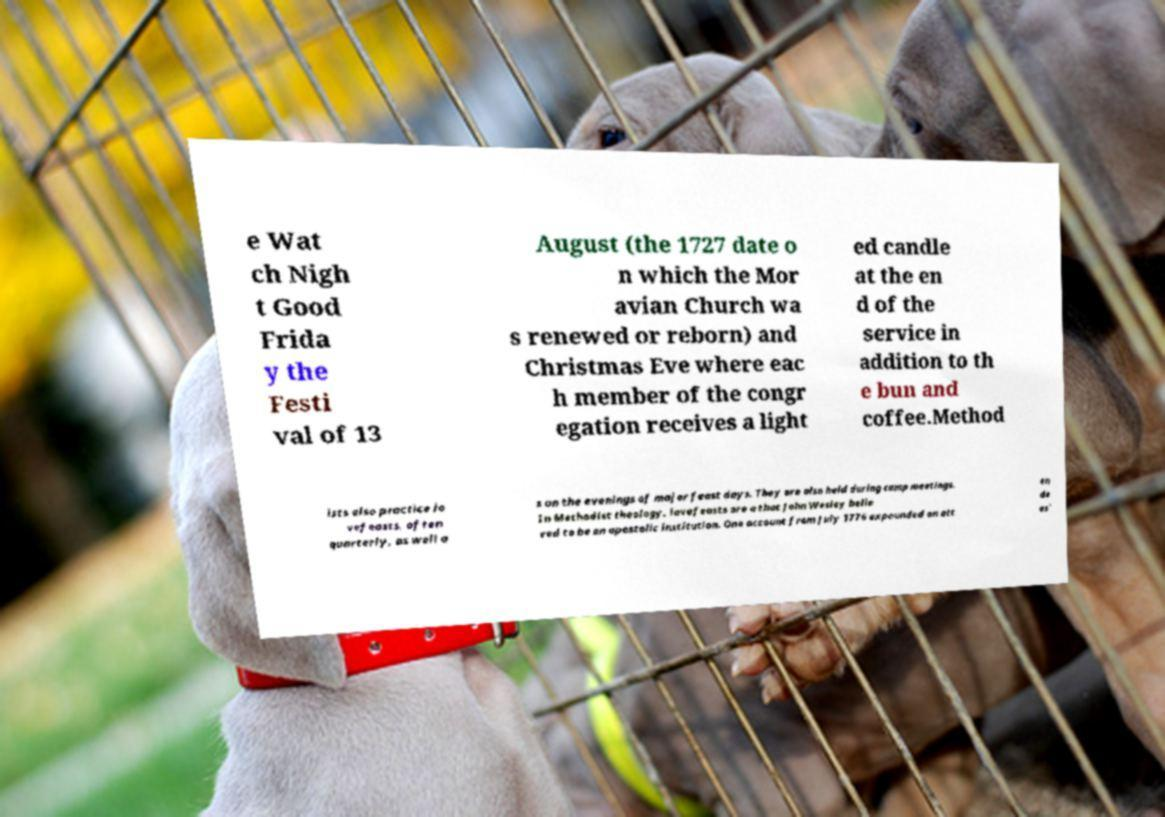Could you assist in decoding the text presented in this image and type it out clearly? e Wat ch Nigh t Good Frida y the Festi val of 13 August (the 1727 date o n which the Mor avian Church wa s renewed or reborn) and Christmas Eve where eac h member of the congr egation receives a light ed candle at the en d of the service in addition to th e bun and coffee.Method ists also practice lo vefeasts, often quarterly, as well a s on the evenings of major feast days. They are also held during camp meetings. In Methodist theology, lovefeasts are a that John Wesley belie ved to be an apostolic institution. One account from July 1776 expounded on att en de es' 